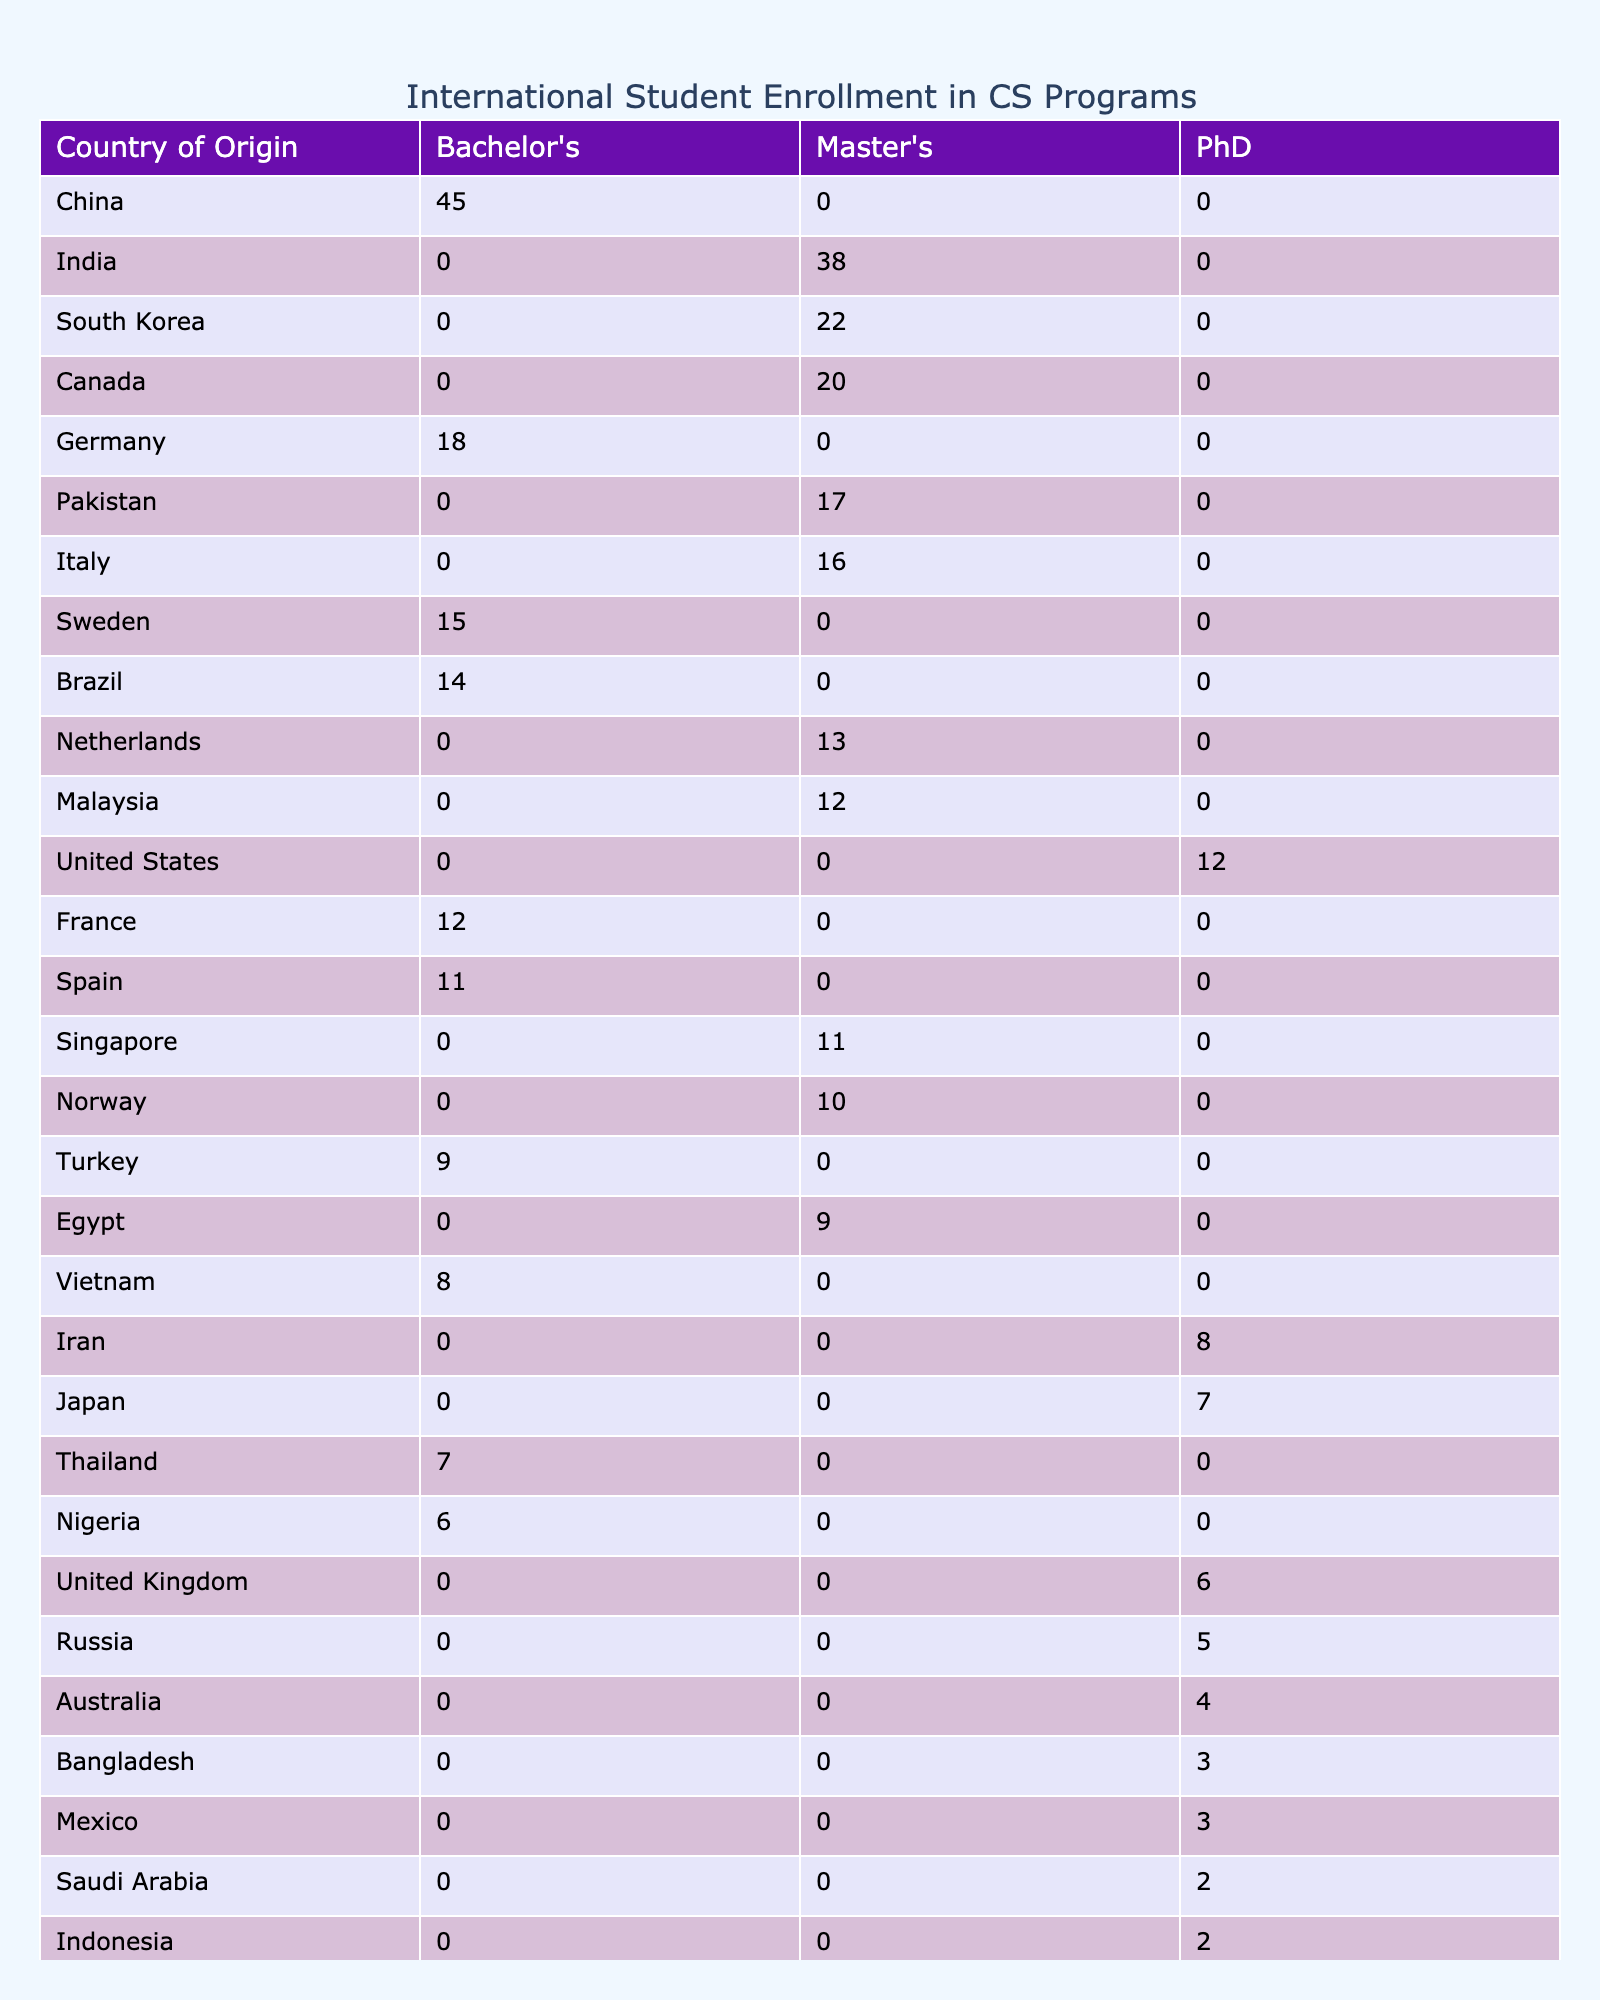What country has the highest number of Bachelor's students? To find the country with the most Bachelor's students, I will look at the "Bachelor's" column and identify the maximum value. In this case, China has 45 students, which is higher than any other country listed in the Bachelor's column.
Answer: China How many Master's students are there from Canada? By examining the "Master's" column under the "Country of Origin" for Canada, I can see that there are 20 Master's students enrolled from Canada.
Answer: 20 Is there any country with no PhD students? I check the "PhD" column across all listed countries. I find that countries like Australia, Saudi Arabia, and Indonesia have fewer than two PhD students. However, there are no countries that have zero PhD students listed.
Answer: No What is the total number of students enrolled from South Korea? The total number of students from South Korea can be determined by adding the number of Master's and PhD students listed. South Korea has 22 Master's students and 0 PhD students, so the total is 22 + 0 = 22.
Answer: 22 Which country contributes the least to the PhD student count? To determine this, I will look for the country listed under PhD with the smallest number of students. In this case, both Bangladesh and Saudi Arabia have 3 and 2 PhD students respectively; thus Saudi Arabia has the least, with only 2 students.
Answer: Saudi Arabia What is the average number of Bachelor's students from the listed countries? To find the average of Bachelor's students, I will sum the numbers for all Bachelor’s programs: 45 (China) + 18 (Germany) + 15 (Sweden) + 14 (Brazil) + 12 (France) + 11 (Spain) + 9 (Turkey) + 8 (Vietnam) + 7 (Thailand) + 6 (Nigeria) = 345. There are 10 countries providing Bachelor's students, so the average is 345 / 10 = 34.5.
Answer: 34.5 Which degree level has the most total students? I will sum the total students in each degree level. For Master's it is 38 (India) + 22 (South Korea) + 10 (Norway) + 20 (Canada) + 16 (Italy) + 17 (Pakistan) + 12 (Malaysia) + 11 (Singapore) + 9 (Egypt) = 155. For Bachelor's it sums to 345 as calculated before. For PhD: 12 (United States) + 8 (Iran) + 6 (United Kingdom) + 7 (Japan) + 5 (Russia) + 4 (Australia) + 3 (Bangladesh) + 2 (Indonesia) + 3 (Mexico) + 2 (Saudi Arabia) = 52. The highest total is for Bachelor's with 345.
Answer: Bachelor's How many countries have more than 10 Master's students? I will go through the Master's column and count how many countries have student counts greater than 10. The countries are: India (38), South Korea (22), Norway (10), Canada (20), Italy (16), Pakistan (17), Malaysia (12), and Singapore (11). That totals to 8 countries.
Answer: 8 